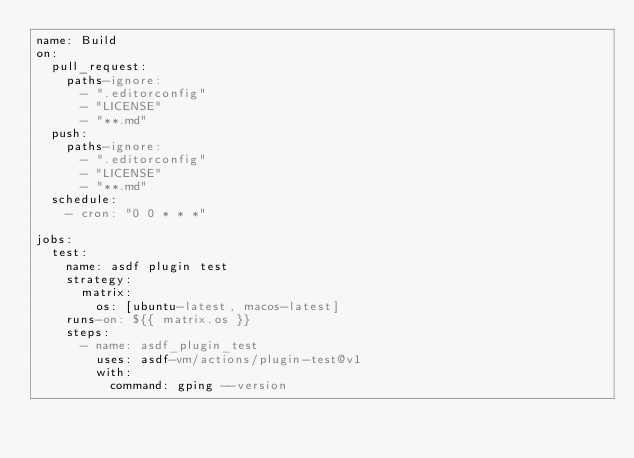<code> <loc_0><loc_0><loc_500><loc_500><_YAML_>name: Build
on:
  pull_request:
    paths-ignore:
      - ".editorconfig"
      - "LICENSE"
      - "**.md"
  push:
    paths-ignore:
      - ".editorconfig"
      - "LICENSE"
      - "**.md"
  schedule:
    - cron: "0 0 * * *"

jobs:
  test:
    name: asdf plugin test
    strategy:
      matrix:
        os: [ubuntu-latest, macos-latest]
    runs-on: ${{ matrix.os }}
    steps:
      - name: asdf_plugin_test
        uses: asdf-vm/actions/plugin-test@v1
        with:
          command: gping --version
</code> 